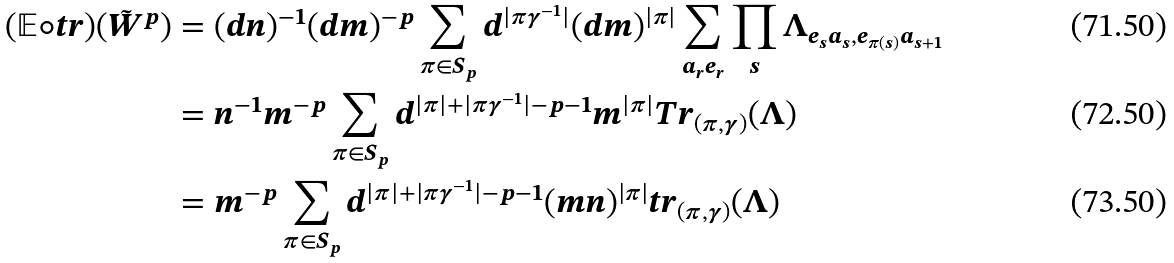<formula> <loc_0><loc_0><loc_500><loc_500>( \mathbb { E } \circ t r ) ( \tilde { W } ^ { p } ) & = ( d n ) ^ { - 1 } ( d m ) ^ { - p } \sum _ { \pi \in S _ { p } } d ^ { | \pi \gamma ^ { - 1 } | } ( d m ) ^ { | \pi | } \sum _ { a _ { r } e _ { r } } \prod _ { s } \Lambda _ { e _ { s } a _ { s } , e _ { \pi ( s ) } a _ { s + 1 } } \\ & = n ^ { - 1 } m ^ { - p } \sum _ { \pi \in S _ { p } } d ^ { | \pi | + | \pi \gamma ^ { - 1 } | - p - 1 } m ^ { | \pi | } T r _ { ( \pi , \gamma ) } ( \Lambda ) \\ & = m ^ { - p } \sum _ { \pi \in S _ { p } } d ^ { | \pi | + | \pi \gamma ^ { - 1 } | - p - 1 } ( m n ) ^ { | \pi | } t r _ { ( \pi , \gamma ) } ( \Lambda )</formula> 